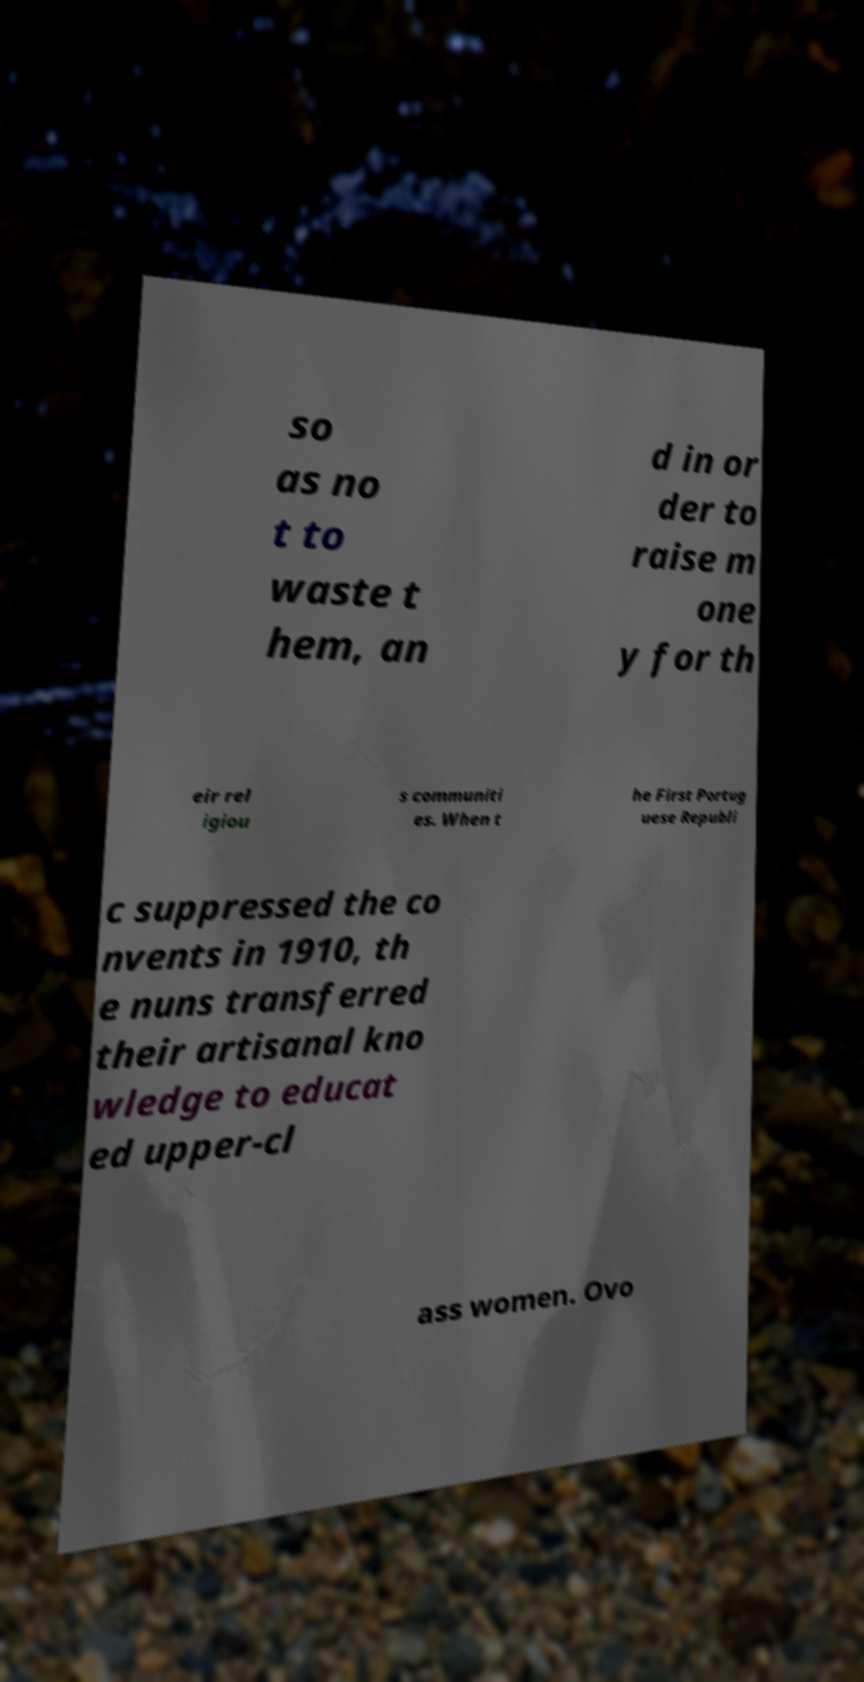Can you read and provide the text displayed in the image?This photo seems to have some interesting text. Can you extract and type it out for me? so as no t to waste t hem, an d in or der to raise m one y for th eir rel igiou s communiti es. When t he First Portug uese Republi c suppressed the co nvents in 1910, th e nuns transferred their artisanal kno wledge to educat ed upper-cl ass women. Ovo 